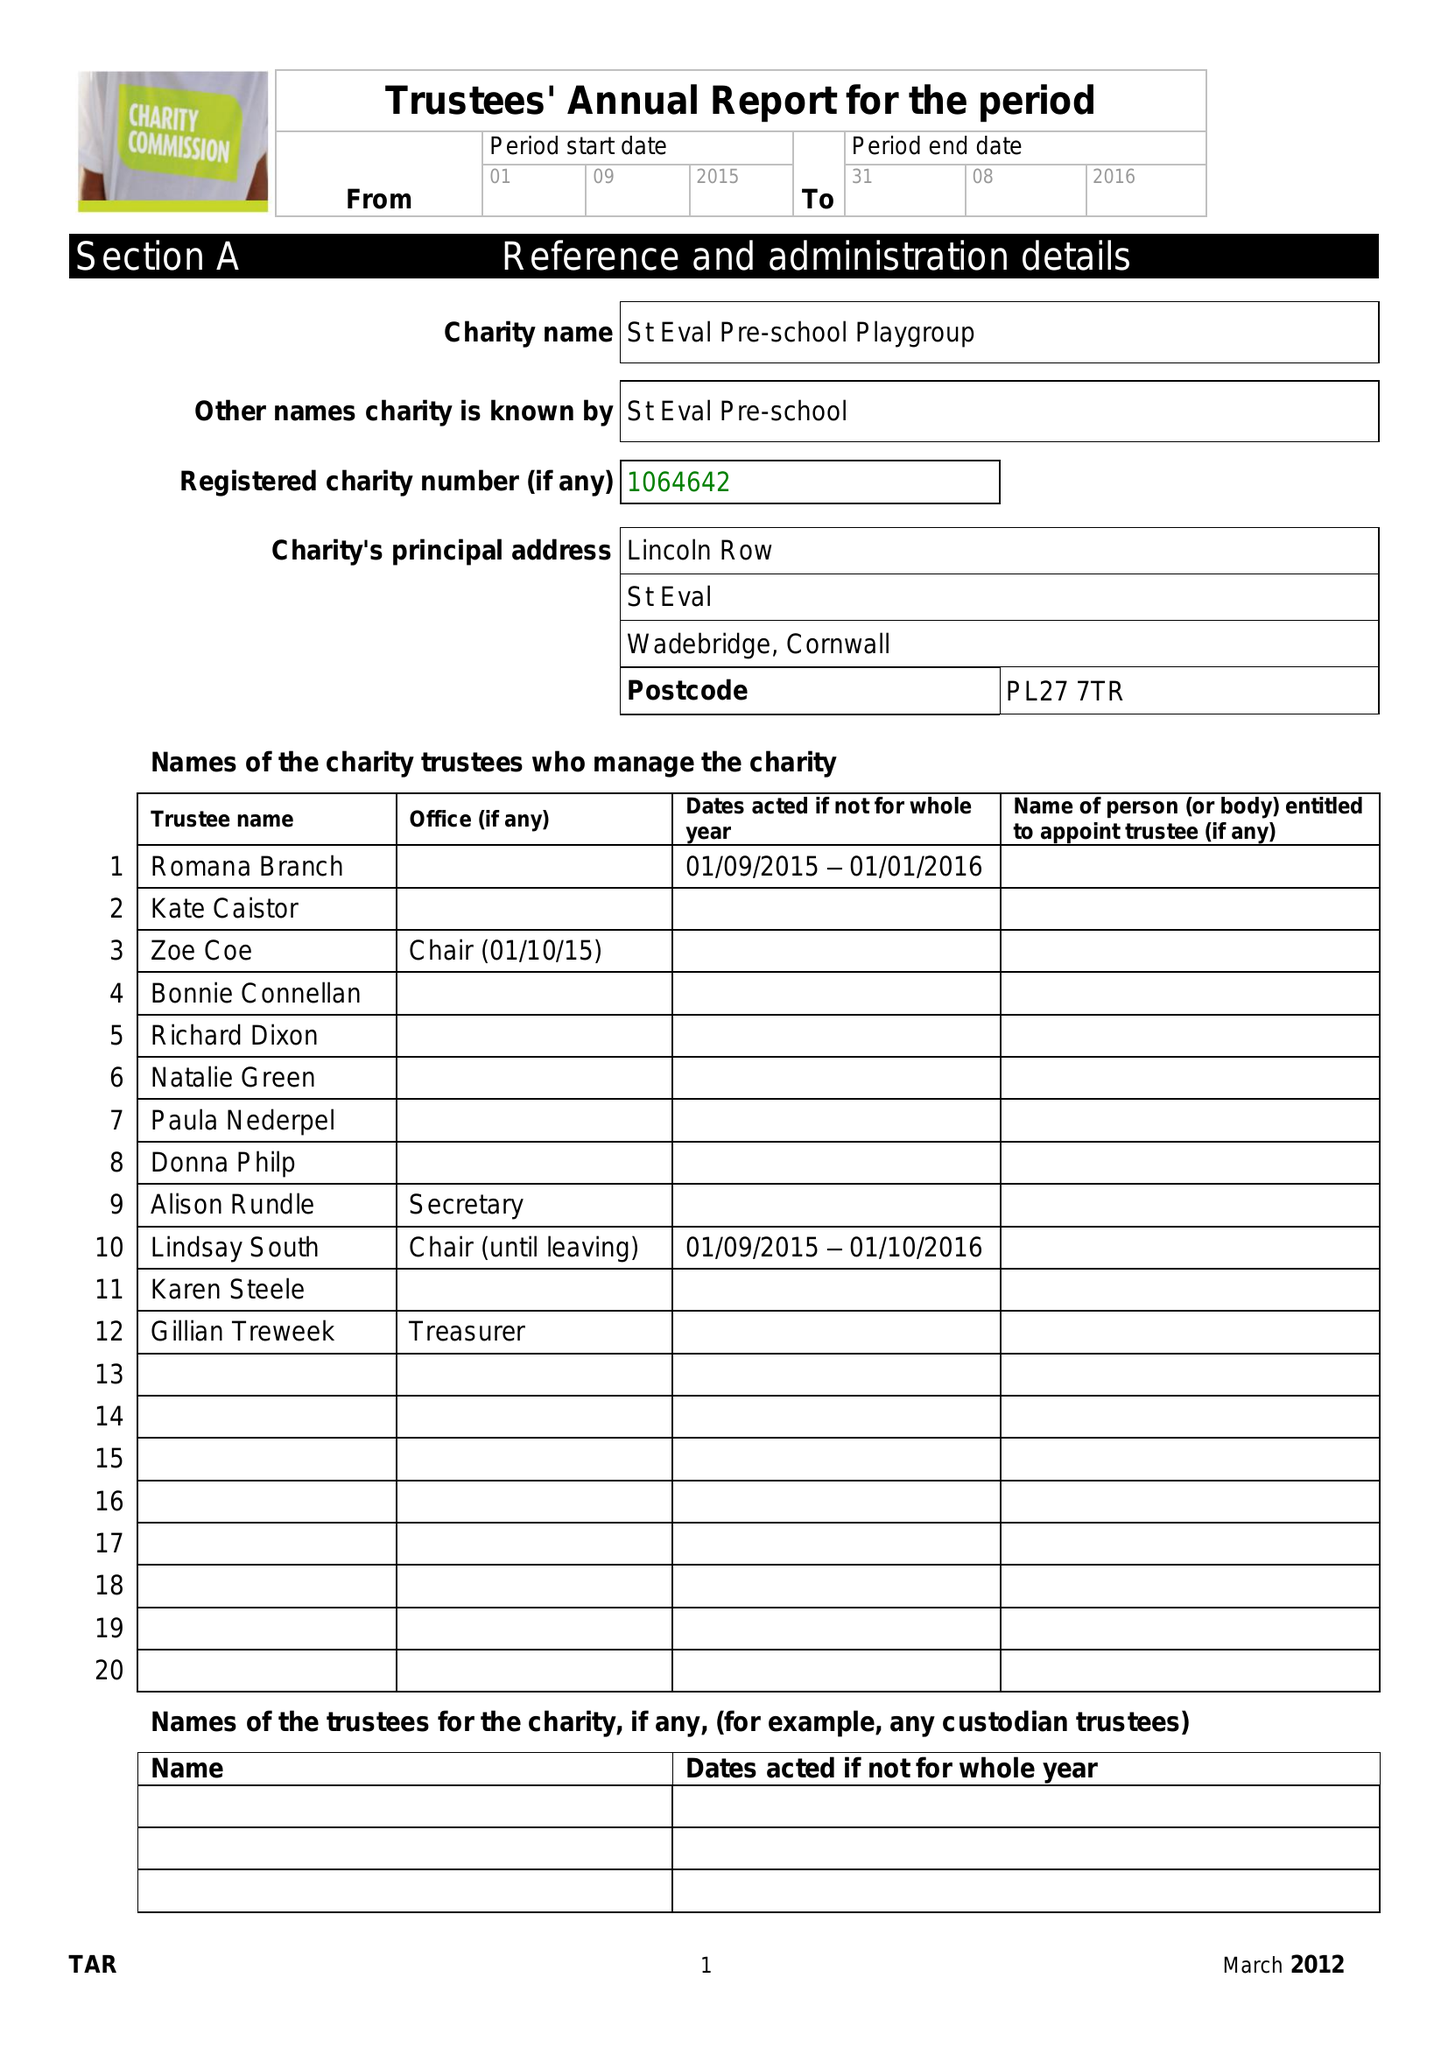What is the value for the spending_annually_in_british_pounds?
Answer the question using a single word or phrase. 114507.68 